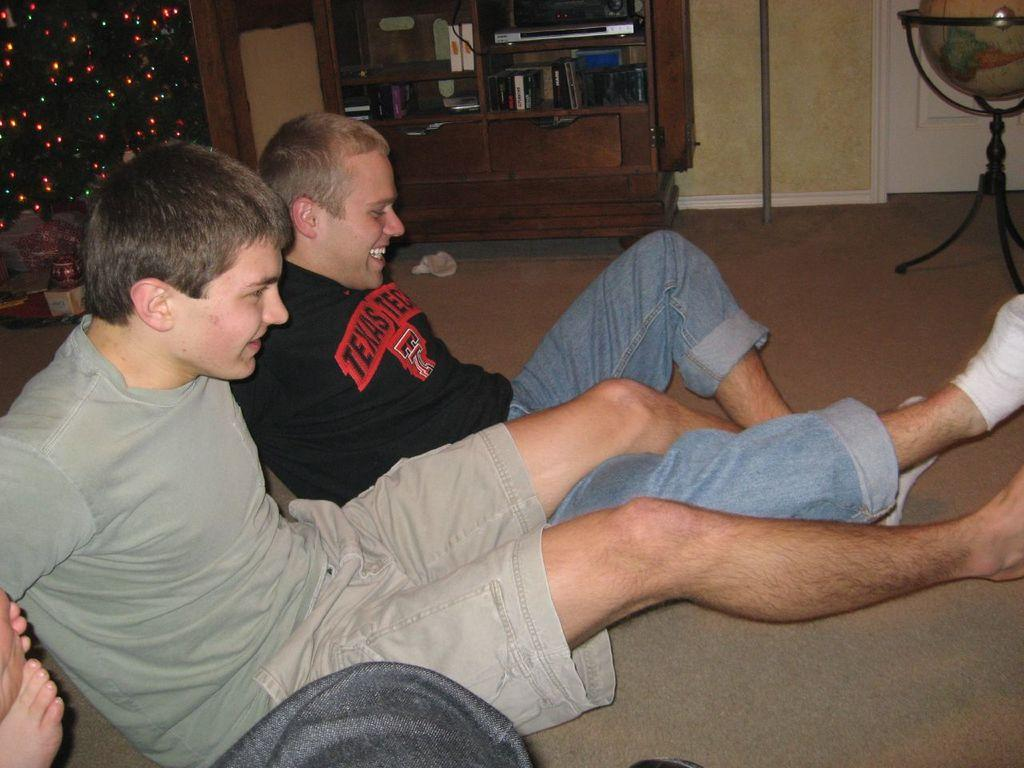<image>
Present a compact description of the photo's key features. A man with the word Texas on his shirt sits on the floor with a friend. 